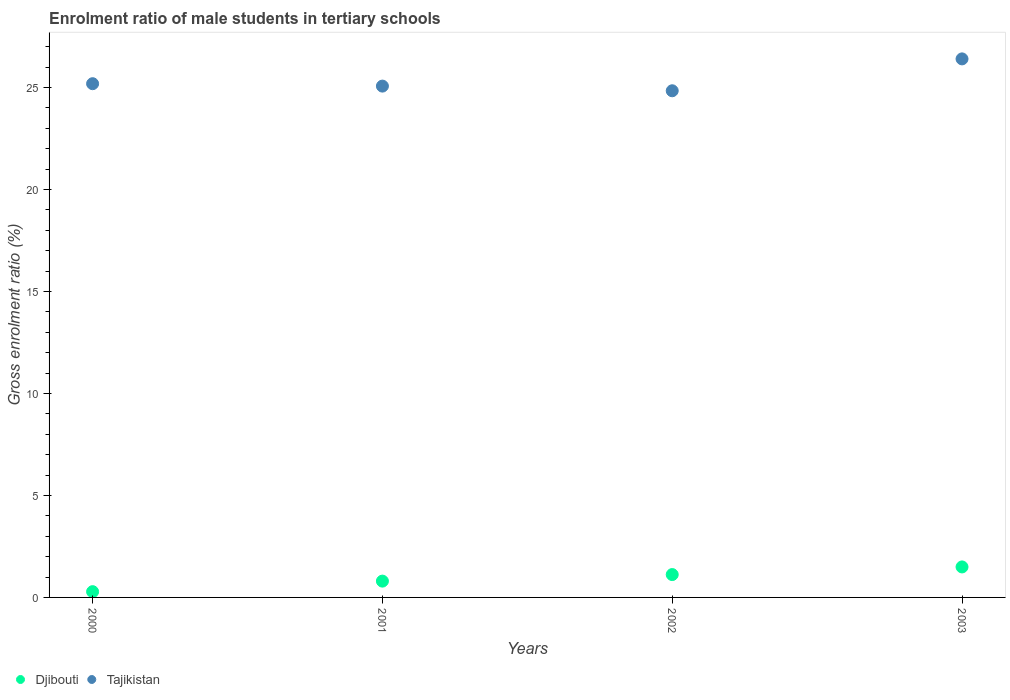How many different coloured dotlines are there?
Provide a short and direct response. 2. Is the number of dotlines equal to the number of legend labels?
Give a very brief answer. Yes. What is the enrolment ratio of male students in tertiary schools in Tajikistan in 2002?
Provide a short and direct response. 24.84. Across all years, what is the maximum enrolment ratio of male students in tertiary schools in Tajikistan?
Give a very brief answer. 26.41. Across all years, what is the minimum enrolment ratio of male students in tertiary schools in Djibouti?
Your response must be concise. 0.28. In which year was the enrolment ratio of male students in tertiary schools in Tajikistan minimum?
Keep it short and to the point. 2002. What is the total enrolment ratio of male students in tertiary schools in Djibouti in the graph?
Make the answer very short. 3.7. What is the difference between the enrolment ratio of male students in tertiary schools in Djibouti in 2001 and that in 2003?
Ensure brevity in your answer.  -0.7. What is the difference between the enrolment ratio of male students in tertiary schools in Tajikistan in 2002 and the enrolment ratio of male students in tertiary schools in Djibouti in 2000?
Your answer should be very brief. 24.56. What is the average enrolment ratio of male students in tertiary schools in Tajikistan per year?
Your answer should be very brief. 25.38. In the year 2000, what is the difference between the enrolment ratio of male students in tertiary schools in Djibouti and enrolment ratio of male students in tertiary schools in Tajikistan?
Your response must be concise. -24.91. In how many years, is the enrolment ratio of male students in tertiary schools in Djibouti greater than 4 %?
Give a very brief answer. 0. What is the ratio of the enrolment ratio of male students in tertiary schools in Djibouti in 2000 to that in 2002?
Your response must be concise. 0.25. Is the difference between the enrolment ratio of male students in tertiary schools in Djibouti in 2001 and 2002 greater than the difference between the enrolment ratio of male students in tertiary schools in Tajikistan in 2001 and 2002?
Keep it short and to the point. No. What is the difference between the highest and the second highest enrolment ratio of male students in tertiary schools in Djibouti?
Offer a very short reply. 0.37. What is the difference between the highest and the lowest enrolment ratio of male students in tertiary schools in Tajikistan?
Keep it short and to the point. 1.56. Does the enrolment ratio of male students in tertiary schools in Tajikistan monotonically increase over the years?
Give a very brief answer. No. Is the enrolment ratio of male students in tertiary schools in Djibouti strictly greater than the enrolment ratio of male students in tertiary schools in Tajikistan over the years?
Ensure brevity in your answer.  No. Is the enrolment ratio of male students in tertiary schools in Djibouti strictly less than the enrolment ratio of male students in tertiary schools in Tajikistan over the years?
Give a very brief answer. Yes. What is the difference between two consecutive major ticks on the Y-axis?
Provide a succinct answer. 5. Are the values on the major ticks of Y-axis written in scientific E-notation?
Provide a succinct answer. No. Does the graph contain grids?
Keep it short and to the point. No. Where does the legend appear in the graph?
Offer a terse response. Bottom left. How many legend labels are there?
Ensure brevity in your answer.  2. How are the legend labels stacked?
Provide a succinct answer. Horizontal. What is the title of the graph?
Your answer should be very brief. Enrolment ratio of male students in tertiary schools. Does "Oman" appear as one of the legend labels in the graph?
Keep it short and to the point. No. What is the label or title of the X-axis?
Offer a very short reply. Years. What is the Gross enrolment ratio (%) in Djibouti in 2000?
Offer a terse response. 0.28. What is the Gross enrolment ratio (%) of Tajikistan in 2000?
Keep it short and to the point. 25.19. What is the Gross enrolment ratio (%) in Djibouti in 2001?
Provide a short and direct response. 0.8. What is the Gross enrolment ratio (%) in Tajikistan in 2001?
Keep it short and to the point. 25.07. What is the Gross enrolment ratio (%) of Djibouti in 2002?
Keep it short and to the point. 1.12. What is the Gross enrolment ratio (%) in Tajikistan in 2002?
Ensure brevity in your answer.  24.84. What is the Gross enrolment ratio (%) of Djibouti in 2003?
Ensure brevity in your answer.  1.5. What is the Gross enrolment ratio (%) of Tajikistan in 2003?
Make the answer very short. 26.41. Across all years, what is the maximum Gross enrolment ratio (%) of Djibouti?
Your answer should be compact. 1.5. Across all years, what is the maximum Gross enrolment ratio (%) in Tajikistan?
Provide a succinct answer. 26.41. Across all years, what is the minimum Gross enrolment ratio (%) in Djibouti?
Offer a terse response. 0.28. Across all years, what is the minimum Gross enrolment ratio (%) of Tajikistan?
Your answer should be very brief. 24.84. What is the total Gross enrolment ratio (%) of Djibouti in the graph?
Your response must be concise. 3.7. What is the total Gross enrolment ratio (%) of Tajikistan in the graph?
Offer a very short reply. 101.51. What is the difference between the Gross enrolment ratio (%) in Djibouti in 2000 and that in 2001?
Your answer should be very brief. -0.52. What is the difference between the Gross enrolment ratio (%) in Tajikistan in 2000 and that in 2001?
Your answer should be compact. 0.12. What is the difference between the Gross enrolment ratio (%) in Djibouti in 2000 and that in 2002?
Ensure brevity in your answer.  -0.84. What is the difference between the Gross enrolment ratio (%) of Tajikistan in 2000 and that in 2002?
Provide a succinct answer. 0.35. What is the difference between the Gross enrolment ratio (%) of Djibouti in 2000 and that in 2003?
Make the answer very short. -1.21. What is the difference between the Gross enrolment ratio (%) in Tajikistan in 2000 and that in 2003?
Your answer should be very brief. -1.22. What is the difference between the Gross enrolment ratio (%) of Djibouti in 2001 and that in 2002?
Ensure brevity in your answer.  -0.32. What is the difference between the Gross enrolment ratio (%) in Tajikistan in 2001 and that in 2002?
Make the answer very short. 0.23. What is the difference between the Gross enrolment ratio (%) in Djibouti in 2001 and that in 2003?
Your response must be concise. -0.7. What is the difference between the Gross enrolment ratio (%) in Tajikistan in 2001 and that in 2003?
Keep it short and to the point. -1.33. What is the difference between the Gross enrolment ratio (%) in Djibouti in 2002 and that in 2003?
Your answer should be very brief. -0.37. What is the difference between the Gross enrolment ratio (%) in Tajikistan in 2002 and that in 2003?
Provide a succinct answer. -1.56. What is the difference between the Gross enrolment ratio (%) of Djibouti in 2000 and the Gross enrolment ratio (%) of Tajikistan in 2001?
Keep it short and to the point. -24.79. What is the difference between the Gross enrolment ratio (%) in Djibouti in 2000 and the Gross enrolment ratio (%) in Tajikistan in 2002?
Give a very brief answer. -24.56. What is the difference between the Gross enrolment ratio (%) in Djibouti in 2000 and the Gross enrolment ratio (%) in Tajikistan in 2003?
Provide a succinct answer. -26.12. What is the difference between the Gross enrolment ratio (%) in Djibouti in 2001 and the Gross enrolment ratio (%) in Tajikistan in 2002?
Ensure brevity in your answer.  -24.04. What is the difference between the Gross enrolment ratio (%) in Djibouti in 2001 and the Gross enrolment ratio (%) in Tajikistan in 2003?
Provide a succinct answer. -25.61. What is the difference between the Gross enrolment ratio (%) in Djibouti in 2002 and the Gross enrolment ratio (%) in Tajikistan in 2003?
Your response must be concise. -25.29. What is the average Gross enrolment ratio (%) of Djibouti per year?
Make the answer very short. 0.92. What is the average Gross enrolment ratio (%) in Tajikistan per year?
Offer a very short reply. 25.38. In the year 2000, what is the difference between the Gross enrolment ratio (%) of Djibouti and Gross enrolment ratio (%) of Tajikistan?
Keep it short and to the point. -24.91. In the year 2001, what is the difference between the Gross enrolment ratio (%) in Djibouti and Gross enrolment ratio (%) in Tajikistan?
Ensure brevity in your answer.  -24.27. In the year 2002, what is the difference between the Gross enrolment ratio (%) of Djibouti and Gross enrolment ratio (%) of Tajikistan?
Ensure brevity in your answer.  -23.72. In the year 2003, what is the difference between the Gross enrolment ratio (%) in Djibouti and Gross enrolment ratio (%) in Tajikistan?
Offer a terse response. -24.91. What is the ratio of the Gross enrolment ratio (%) of Djibouti in 2000 to that in 2001?
Offer a terse response. 0.35. What is the ratio of the Gross enrolment ratio (%) of Tajikistan in 2000 to that in 2001?
Make the answer very short. 1. What is the ratio of the Gross enrolment ratio (%) in Djibouti in 2000 to that in 2002?
Offer a very short reply. 0.25. What is the ratio of the Gross enrolment ratio (%) of Tajikistan in 2000 to that in 2002?
Keep it short and to the point. 1.01. What is the ratio of the Gross enrolment ratio (%) in Djibouti in 2000 to that in 2003?
Your response must be concise. 0.19. What is the ratio of the Gross enrolment ratio (%) in Tajikistan in 2000 to that in 2003?
Your response must be concise. 0.95. What is the ratio of the Gross enrolment ratio (%) of Djibouti in 2001 to that in 2002?
Your answer should be compact. 0.71. What is the ratio of the Gross enrolment ratio (%) of Tajikistan in 2001 to that in 2002?
Ensure brevity in your answer.  1.01. What is the ratio of the Gross enrolment ratio (%) of Djibouti in 2001 to that in 2003?
Offer a very short reply. 0.53. What is the ratio of the Gross enrolment ratio (%) in Tajikistan in 2001 to that in 2003?
Offer a very short reply. 0.95. What is the ratio of the Gross enrolment ratio (%) of Djibouti in 2002 to that in 2003?
Keep it short and to the point. 0.75. What is the ratio of the Gross enrolment ratio (%) of Tajikistan in 2002 to that in 2003?
Offer a very short reply. 0.94. What is the difference between the highest and the second highest Gross enrolment ratio (%) of Djibouti?
Make the answer very short. 0.37. What is the difference between the highest and the second highest Gross enrolment ratio (%) in Tajikistan?
Provide a short and direct response. 1.22. What is the difference between the highest and the lowest Gross enrolment ratio (%) in Djibouti?
Offer a terse response. 1.21. What is the difference between the highest and the lowest Gross enrolment ratio (%) of Tajikistan?
Your response must be concise. 1.56. 